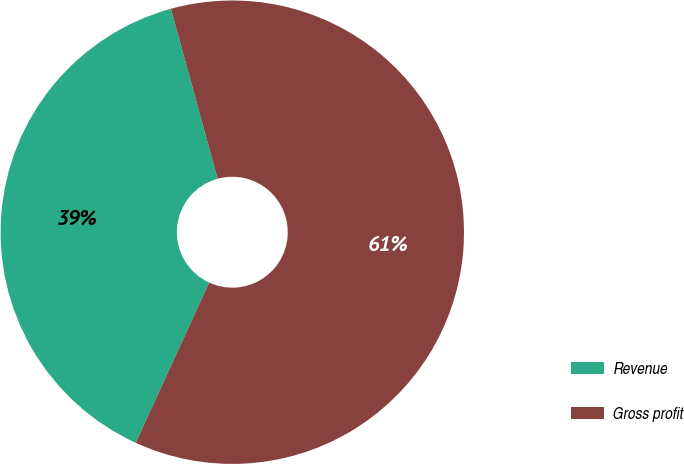<chart> <loc_0><loc_0><loc_500><loc_500><pie_chart><fcel>Revenue<fcel>Gross profit<nl><fcel>38.89%<fcel>61.11%<nl></chart> 